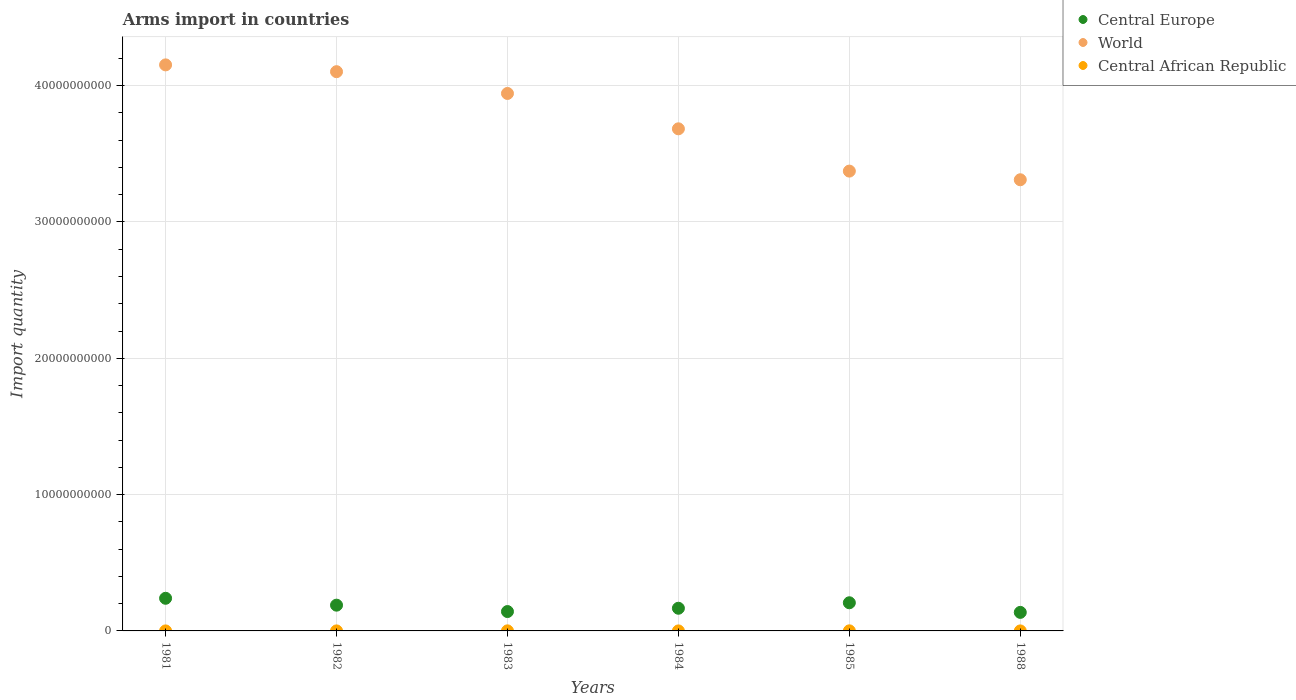How many different coloured dotlines are there?
Make the answer very short. 3. Is the number of dotlines equal to the number of legend labels?
Your answer should be very brief. Yes. What is the total arms import in Central Europe in 1985?
Your response must be concise. 2.06e+09. Across all years, what is the maximum total arms import in Central Europe?
Offer a terse response. 2.39e+09. Across all years, what is the minimum total arms import in Central Europe?
Offer a terse response. 1.36e+09. In which year was the total arms import in World minimum?
Offer a terse response. 1988. What is the total total arms import in Central Europe in the graph?
Offer a terse response. 1.08e+1. What is the difference between the total arms import in World in 1983 and that in 1988?
Give a very brief answer. 6.33e+09. What is the difference between the total arms import in World in 1988 and the total arms import in Central African Republic in 1983?
Ensure brevity in your answer.  3.31e+1. What is the average total arms import in Central African Republic per year?
Your response must be concise. 2.67e+06. In the year 1981, what is the difference between the total arms import in Central African Republic and total arms import in World?
Your answer should be compact. -4.15e+1. In how many years, is the total arms import in World greater than 20000000000?
Ensure brevity in your answer.  6. What is the ratio of the total arms import in World in 1985 to that in 1988?
Your answer should be very brief. 1.02. Is the difference between the total arms import in Central African Republic in 1981 and 1982 greater than the difference between the total arms import in World in 1981 and 1982?
Offer a terse response. No. What is the difference between the highest and the second highest total arms import in World?
Provide a short and direct response. 4.99e+08. Is it the case that in every year, the sum of the total arms import in Central Europe and total arms import in Central African Republic  is greater than the total arms import in World?
Provide a succinct answer. No. What is the difference between two consecutive major ticks on the Y-axis?
Give a very brief answer. 1.00e+1. Are the values on the major ticks of Y-axis written in scientific E-notation?
Offer a terse response. No. Does the graph contain any zero values?
Offer a terse response. No. Where does the legend appear in the graph?
Provide a succinct answer. Top right. What is the title of the graph?
Provide a succinct answer. Arms import in countries. What is the label or title of the Y-axis?
Ensure brevity in your answer.  Import quantity. What is the Import quantity of Central Europe in 1981?
Offer a terse response. 2.39e+09. What is the Import quantity in World in 1981?
Keep it short and to the point. 4.15e+1. What is the Import quantity of Central Europe in 1982?
Your response must be concise. 1.89e+09. What is the Import quantity in World in 1982?
Provide a succinct answer. 4.10e+1. What is the Import quantity of Central African Republic in 1982?
Make the answer very short. 2.00e+06. What is the Import quantity in Central Europe in 1983?
Provide a short and direct response. 1.42e+09. What is the Import quantity of World in 1983?
Make the answer very short. 3.94e+1. What is the Import quantity of Central African Republic in 1983?
Offer a terse response. 5.00e+06. What is the Import quantity in Central Europe in 1984?
Offer a terse response. 1.66e+09. What is the Import quantity of World in 1984?
Give a very brief answer. 3.68e+1. What is the Import quantity of Central African Republic in 1984?
Your response must be concise. 1.00e+06. What is the Import quantity of Central Europe in 1985?
Your answer should be compact. 2.06e+09. What is the Import quantity in World in 1985?
Keep it short and to the point. 3.37e+1. What is the Import quantity in Central Europe in 1988?
Your answer should be compact. 1.36e+09. What is the Import quantity in World in 1988?
Your answer should be compact. 3.31e+1. What is the Import quantity of Central African Republic in 1988?
Your answer should be compact. 1.00e+06. Across all years, what is the maximum Import quantity in Central Europe?
Keep it short and to the point. 2.39e+09. Across all years, what is the maximum Import quantity in World?
Your answer should be very brief. 4.15e+1. Across all years, what is the maximum Import quantity of Central African Republic?
Make the answer very short. 6.00e+06. Across all years, what is the minimum Import quantity of Central Europe?
Offer a very short reply. 1.36e+09. Across all years, what is the minimum Import quantity of World?
Ensure brevity in your answer.  3.31e+1. Across all years, what is the minimum Import quantity in Central African Republic?
Keep it short and to the point. 1.00e+06. What is the total Import quantity in Central Europe in the graph?
Provide a short and direct response. 1.08e+1. What is the total Import quantity of World in the graph?
Provide a short and direct response. 2.26e+11. What is the total Import quantity in Central African Republic in the graph?
Your answer should be very brief. 1.60e+07. What is the difference between the Import quantity of Central Europe in 1981 and that in 1982?
Offer a very short reply. 5.05e+08. What is the difference between the Import quantity in World in 1981 and that in 1982?
Make the answer very short. 4.99e+08. What is the difference between the Import quantity of Central African Republic in 1981 and that in 1982?
Keep it short and to the point. -1.00e+06. What is the difference between the Import quantity in Central Europe in 1981 and that in 1983?
Your response must be concise. 9.73e+08. What is the difference between the Import quantity of World in 1981 and that in 1983?
Keep it short and to the point. 2.10e+09. What is the difference between the Import quantity of Central Europe in 1981 and that in 1984?
Provide a short and direct response. 7.31e+08. What is the difference between the Import quantity of World in 1981 and that in 1984?
Give a very brief answer. 4.69e+09. What is the difference between the Import quantity of Central Europe in 1981 and that in 1985?
Offer a terse response. 3.29e+08. What is the difference between the Import quantity in World in 1981 and that in 1985?
Ensure brevity in your answer.  7.79e+09. What is the difference between the Import quantity of Central African Republic in 1981 and that in 1985?
Your answer should be very brief. -5.00e+06. What is the difference between the Import quantity of Central Europe in 1981 and that in 1988?
Your answer should be very brief. 1.03e+09. What is the difference between the Import quantity in World in 1981 and that in 1988?
Your answer should be very brief. 8.43e+09. What is the difference between the Import quantity of Central Europe in 1982 and that in 1983?
Offer a very short reply. 4.68e+08. What is the difference between the Import quantity in World in 1982 and that in 1983?
Make the answer very short. 1.60e+09. What is the difference between the Import quantity in Central African Republic in 1982 and that in 1983?
Offer a very short reply. -3.00e+06. What is the difference between the Import quantity in Central Europe in 1982 and that in 1984?
Your answer should be compact. 2.26e+08. What is the difference between the Import quantity in World in 1982 and that in 1984?
Give a very brief answer. 4.19e+09. What is the difference between the Import quantity of Central Europe in 1982 and that in 1985?
Your response must be concise. -1.76e+08. What is the difference between the Import quantity in World in 1982 and that in 1985?
Provide a short and direct response. 7.29e+09. What is the difference between the Import quantity of Central Europe in 1982 and that in 1988?
Your response must be concise. 5.29e+08. What is the difference between the Import quantity in World in 1982 and that in 1988?
Your answer should be very brief. 7.93e+09. What is the difference between the Import quantity in Central Europe in 1983 and that in 1984?
Offer a terse response. -2.42e+08. What is the difference between the Import quantity in World in 1983 and that in 1984?
Your answer should be very brief. 2.59e+09. What is the difference between the Import quantity of Central Europe in 1983 and that in 1985?
Provide a short and direct response. -6.44e+08. What is the difference between the Import quantity of World in 1983 and that in 1985?
Your answer should be compact. 5.70e+09. What is the difference between the Import quantity of Central Europe in 1983 and that in 1988?
Your answer should be very brief. 6.10e+07. What is the difference between the Import quantity in World in 1983 and that in 1988?
Your response must be concise. 6.33e+09. What is the difference between the Import quantity in Central Europe in 1984 and that in 1985?
Your response must be concise. -4.02e+08. What is the difference between the Import quantity in World in 1984 and that in 1985?
Your answer should be compact. 3.10e+09. What is the difference between the Import quantity in Central African Republic in 1984 and that in 1985?
Give a very brief answer. -5.00e+06. What is the difference between the Import quantity of Central Europe in 1984 and that in 1988?
Offer a terse response. 3.03e+08. What is the difference between the Import quantity of World in 1984 and that in 1988?
Provide a short and direct response. 3.74e+09. What is the difference between the Import quantity in Central Europe in 1985 and that in 1988?
Your response must be concise. 7.05e+08. What is the difference between the Import quantity in World in 1985 and that in 1988?
Offer a very short reply. 6.35e+08. What is the difference between the Import quantity in Central African Republic in 1985 and that in 1988?
Make the answer very short. 5.00e+06. What is the difference between the Import quantity of Central Europe in 1981 and the Import quantity of World in 1982?
Offer a very short reply. -3.86e+1. What is the difference between the Import quantity in Central Europe in 1981 and the Import quantity in Central African Republic in 1982?
Offer a very short reply. 2.39e+09. What is the difference between the Import quantity in World in 1981 and the Import quantity in Central African Republic in 1982?
Provide a short and direct response. 4.15e+1. What is the difference between the Import quantity in Central Europe in 1981 and the Import quantity in World in 1983?
Keep it short and to the point. -3.70e+1. What is the difference between the Import quantity in Central Europe in 1981 and the Import quantity in Central African Republic in 1983?
Keep it short and to the point. 2.39e+09. What is the difference between the Import quantity in World in 1981 and the Import quantity in Central African Republic in 1983?
Your response must be concise. 4.15e+1. What is the difference between the Import quantity of Central Europe in 1981 and the Import quantity of World in 1984?
Your answer should be compact. -3.44e+1. What is the difference between the Import quantity of Central Europe in 1981 and the Import quantity of Central African Republic in 1984?
Make the answer very short. 2.39e+09. What is the difference between the Import quantity of World in 1981 and the Import quantity of Central African Republic in 1984?
Make the answer very short. 4.15e+1. What is the difference between the Import quantity in Central Europe in 1981 and the Import quantity in World in 1985?
Keep it short and to the point. -3.13e+1. What is the difference between the Import quantity in Central Europe in 1981 and the Import quantity in Central African Republic in 1985?
Your response must be concise. 2.39e+09. What is the difference between the Import quantity of World in 1981 and the Import quantity of Central African Republic in 1985?
Give a very brief answer. 4.15e+1. What is the difference between the Import quantity in Central Europe in 1981 and the Import quantity in World in 1988?
Give a very brief answer. -3.07e+1. What is the difference between the Import quantity of Central Europe in 1981 and the Import quantity of Central African Republic in 1988?
Provide a short and direct response. 2.39e+09. What is the difference between the Import quantity of World in 1981 and the Import quantity of Central African Republic in 1988?
Provide a short and direct response. 4.15e+1. What is the difference between the Import quantity of Central Europe in 1982 and the Import quantity of World in 1983?
Offer a very short reply. -3.75e+1. What is the difference between the Import quantity of Central Europe in 1982 and the Import quantity of Central African Republic in 1983?
Offer a terse response. 1.88e+09. What is the difference between the Import quantity in World in 1982 and the Import quantity in Central African Republic in 1983?
Give a very brief answer. 4.10e+1. What is the difference between the Import quantity of Central Europe in 1982 and the Import quantity of World in 1984?
Your answer should be very brief. -3.49e+1. What is the difference between the Import quantity of Central Europe in 1982 and the Import quantity of Central African Republic in 1984?
Keep it short and to the point. 1.89e+09. What is the difference between the Import quantity in World in 1982 and the Import quantity in Central African Republic in 1984?
Offer a very short reply. 4.10e+1. What is the difference between the Import quantity in Central Europe in 1982 and the Import quantity in World in 1985?
Offer a terse response. -3.18e+1. What is the difference between the Import quantity of Central Europe in 1982 and the Import quantity of Central African Republic in 1985?
Your answer should be compact. 1.88e+09. What is the difference between the Import quantity in World in 1982 and the Import quantity in Central African Republic in 1985?
Provide a short and direct response. 4.10e+1. What is the difference between the Import quantity in Central Europe in 1982 and the Import quantity in World in 1988?
Keep it short and to the point. -3.12e+1. What is the difference between the Import quantity of Central Europe in 1982 and the Import quantity of Central African Republic in 1988?
Ensure brevity in your answer.  1.89e+09. What is the difference between the Import quantity of World in 1982 and the Import quantity of Central African Republic in 1988?
Keep it short and to the point. 4.10e+1. What is the difference between the Import quantity of Central Europe in 1983 and the Import quantity of World in 1984?
Ensure brevity in your answer.  -3.54e+1. What is the difference between the Import quantity in Central Europe in 1983 and the Import quantity in Central African Republic in 1984?
Give a very brief answer. 1.42e+09. What is the difference between the Import quantity in World in 1983 and the Import quantity in Central African Republic in 1984?
Your response must be concise. 3.94e+1. What is the difference between the Import quantity of Central Europe in 1983 and the Import quantity of World in 1985?
Make the answer very short. -3.23e+1. What is the difference between the Import quantity of Central Europe in 1983 and the Import quantity of Central African Republic in 1985?
Offer a very short reply. 1.42e+09. What is the difference between the Import quantity of World in 1983 and the Import quantity of Central African Republic in 1985?
Your response must be concise. 3.94e+1. What is the difference between the Import quantity in Central Europe in 1983 and the Import quantity in World in 1988?
Offer a very short reply. -3.17e+1. What is the difference between the Import quantity in Central Europe in 1983 and the Import quantity in Central African Republic in 1988?
Make the answer very short. 1.42e+09. What is the difference between the Import quantity of World in 1983 and the Import quantity of Central African Republic in 1988?
Give a very brief answer. 3.94e+1. What is the difference between the Import quantity in Central Europe in 1984 and the Import quantity in World in 1985?
Give a very brief answer. -3.21e+1. What is the difference between the Import quantity in Central Europe in 1984 and the Import quantity in Central African Republic in 1985?
Offer a terse response. 1.66e+09. What is the difference between the Import quantity of World in 1984 and the Import quantity of Central African Republic in 1985?
Offer a very short reply. 3.68e+1. What is the difference between the Import quantity in Central Europe in 1984 and the Import quantity in World in 1988?
Offer a very short reply. -3.14e+1. What is the difference between the Import quantity of Central Europe in 1984 and the Import quantity of Central African Republic in 1988?
Your response must be concise. 1.66e+09. What is the difference between the Import quantity of World in 1984 and the Import quantity of Central African Republic in 1988?
Keep it short and to the point. 3.68e+1. What is the difference between the Import quantity of Central Europe in 1985 and the Import quantity of World in 1988?
Give a very brief answer. -3.10e+1. What is the difference between the Import quantity of Central Europe in 1985 and the Import quantity of Central African Republic in 1988?
Keep it short and to the point. 2.06e+09. What is the difference between the Import quantity of World in 1985 and the Import quantity of Central African Republic in 1988?
Keep it short and to the point. 3.37e+1. What is the average Import quantity of Central Europe per year?
Make the answer very short. 1.80e+09. What is the average Import quantity of World per year?
Your response must be concise. 3.76e+1. What is the average Import quantity in Central African Republic per year?
Give a very brief answer. 2.67e+06. In the year 1981, what is the difference between the Import quantity of Central Europe and Import quantity of World?
Offer a terse response. -3.91e+1. In the year 1981, what is the difference between the Import quantity in Central Europe and Import quantity in Central African Republic?
Make the answer very short. 2.39e+09. In the year 1981, what is the difference between the Import quantity of World and Import quantity of Central African Republic?
Offer a terse response. 4.15e+1. In the year 1982, what is the difference between the Import quantity in Central Europe and Import quantity in World?
Your response must be concise. -3.91e+1. In the year 1982, what is the difference between the Import quantity in Central Europe and Import quantity in Central African Republic?
Keep it short and to the point. 1.89e+09. In the year 1982, what is the difference between the Import quantity in World and Import quantity in Central African Republic?
Your response must be concise. 4.10e+1. In the year 1983, what is the difference between the Import quantity of Central Europe and Import quantity of World?
Provide a succinct answer. -3.80e+1. In the year 1983, what is the difference between the Import quantity in Central Europe and Import quantity in Central African Republic?
Offer a terse response. 1.42e+09. In the year 1983, what is the difference between the Import quantity in World and Import quantity in Central African Republic?
Your answer should be very brief. 3.94e+1. In the year 1984, what is the difference between the Import quantity of Central Europe and Import quantity of World?
Your answer should be compact. -3.52e+1. In the year 1984, what is the difference between the Import quantity of Central Europe and Import quantity of Central African Republic?
Keep it short and to the point. 1.66e+09. In the year 1984, what is the difference between the Import quantity in World and Import quantity in Central African Republic?
Give a very brief answer. 3.68e+1. In the year 1985, what is the difference between the Import quantity in Central Europe and Import quantity in World?
Offer a very short reply. -3.17e+1. In the year 1985, what is the difference between the Import quantity of Central Europe and Import quantity of Central African Republic?
Keep it short and to the point. 2.06e+09. In the year 1985, what is the difference between the Import quantity of World and Import quantity of Central African Republic?
Your answer should be very brief. 3.37e+1. In the year 1988, what is the difference between the Import quantity of Central Europe and Import quantity of World?
Make the answer very short. -3.17e+1. In the year 1988, what is the difference between the Import quantity in Central Europe and Import quantity in Central African Republic?
Your response must be concise. 1.36e+09. In the year 1988, what is the difference between the Import quantity of World and Import quantity of Central African Republic?
Ensure brevity in your answer.  3.31e+1. What is the ratio of the Import quantity in Central Europe in 1981 to that in 1982?
Keep it short and to the point. 1.27. What is the ratio of the Import quantity of World in 1981 to that in 1982?
Your answer should be very brief. 1.01. What is the ratio of the Import quantity in Central Europe in 1981 to that in 1983?
Your answer should be very brief. 1.68. What is the ratio of the Import quantity in World in 1981 to that in 1983?
Your answer should be very brief. 1.05. What is the ratio of the Import quantity of Central African Republic in 1981 to that in 1983?
Provide a short and direct response. 0.2. What is the ratio of the Import quantity of Central Europe in 1981 to that in 1984?
Your answer should be very brief. 1.44. What is the ratio of the Import quantity in World in 1981 to that in 1984?
Your answer should be very brief. 1.13. What is the ratio of the Import quantity of Central African Republic in 1981 to that in 1984?
Offer a very short reply. 1. What is the ratio of the Import quantity of Central Europe in 1981 to that in 1985?
Offer a very short reply. 1.16. What is the ratio of the Import quantity of World in 1981 to that in 1985?
Provide a short and direct response. 1.23. What is the ratio of the Import quantity in Central African Republic in 1981 to that in 1985?
Give a very brief answer. 0.17. What is the ratio of the Import quantity of Central Europe in 1981 to that in 1988?
Your response must be concise. 1.76. What is the ratio of the Import quantity of World in 1981 to that in 1988?
Provide a short and direct response. 1.25. What is the ratio of the Import quantity of Central African Republic in 1981 to that in 1988?
Provide a short and direct response. 1. What is the ratio of the Import quantity of Central Europe in 1982 to that in 1983?
Provide a short and direct response. 1.33. What is the ratio of the Import quantity of World in 1982 to that in 1983?
Provide a short and direct response. 1.04. What is the ratio of the Import quantity in Central African Republic in 1982 to that in 1983?
Provide a succinct answer. 0.4. What is the ratio of the Import quantity of Central Europe in 1982 to that in 1984?
Your answer should be very brief. 1.14. What is the ratio of the Import quantity of World in 1982 to that in 1984?
Make the answer very short. 1.11. What is the ratio of the Import quantity of Central African Republic in 1982 to that in 1984?
Give a very brief answer. 2. What is the ratio of the Import quantity of Central Europe in 1982 to that in 1985?
Your response must be concise. 0.91. What is the ratio of the Import quantity in World in 1982 to that in 1985?
Keep it short and to the point. 1.22. What is the ratio of the Import quantity in Central African Republic in 1982 to that in 1985?
Your response must be concise. 0.33. What is the ratio of the Import quantity in Central Europe in 1982 to that in 1988?
Provide a succinct answer. 1.39. What is the ratio of the Import quantity of World in 1982 to that in 1988?
Ensure brevity in your answer.  1.24. What is the ratio of the Import quantity in Central African Republic in 1982 to that in 1988?
Your response must be concise. 2. What is the ratio of the Import quantity in Central Europe in 1983 to that in 1984?
Make the answer very short. 0.85. What is the ratio of the Import quantity of World in 1983 to that in 1984?
Your response must be concise. 1.07. What is the ratio of the Import quantity in Central African Republic in 1983 to that in 1984?
Give a very brief answer. 5. What is the ratio of the Import quantity of Central Europe in 1983 to that in 1985?
Provide a succinct answer. 0.69. What is the ratio of the Import quantity of World in 1983 to that in 1985?
Keep it short and to the point. 1.17. What is the ratio of the Import quantity of Central African Republic in 1983 to that in 1985?
Provide a short and direct response. 0.83. What is the ratio of the Import quantity in Central Europe in 1983 to that in 1988?
Make the answer very short. 1.04. What is the ratio of the Import quantity of World in 1983 to that in 1988?
Offer a terse response. 1.19. What is the ratio of the Import quantity of Central African Republic in 1983 to that in 1988?
Ensure brevity in your answer.  5. What is the ratio of the Import quantity of Central Europe in 1984 to that in 1985?
Give a very brief answer. 0.81. What is the ratio of the Import quantity of World in 1984 to that in 1985?
Provide a short and direct response. 1.09. What is the ratio of the Import quantity in Central African Republic in 1984 to that in 1985?
Provide a succinct answer. 0.17. What is the ratio of the Import quantity of Central Europe in 1984 to that in 1988?
Your response must be concise. 1.22. What is the ratio of the Import quantity in World in 1984 to that in 1988?
Provide a succinct answer. 1.11. What is the ratio of the Import quantity of Central African Republic in 1984 to that in 1988?
Give a very brief answer. 1. What is the ratio of the Import quantity of Central Europe in 1985 to that in 1988?
Keep it short and to the point. 1.52. What is the ratio of the Import quantity in World in 1985 to that in 1988?
Your answer should be very brief. 1.02. What is the ratio of the Import quantity of Central African Republic in 1985 to that in 1988?
Your answer should be very brief. 6. What is the difference between the highest and the second highest Import quantity of Central Europe?
Your response must be concise. 3.29e+08. What is the difference between the highest and the second highest Import quantity in World?
Make the answer very short. 4.99e+08. What is the difference between the highest and the lowest Import quantity of Central Europe?
Your answer should be very brief. 1.03e+09. What is the difference between the highest and the lowest Import quantity of World?
Give a very brief answer. 8.43e+09. What is the difference between the highest and the lowest Import quantity of Central African Republic?
Make the answer very short. 5.00e+06. 